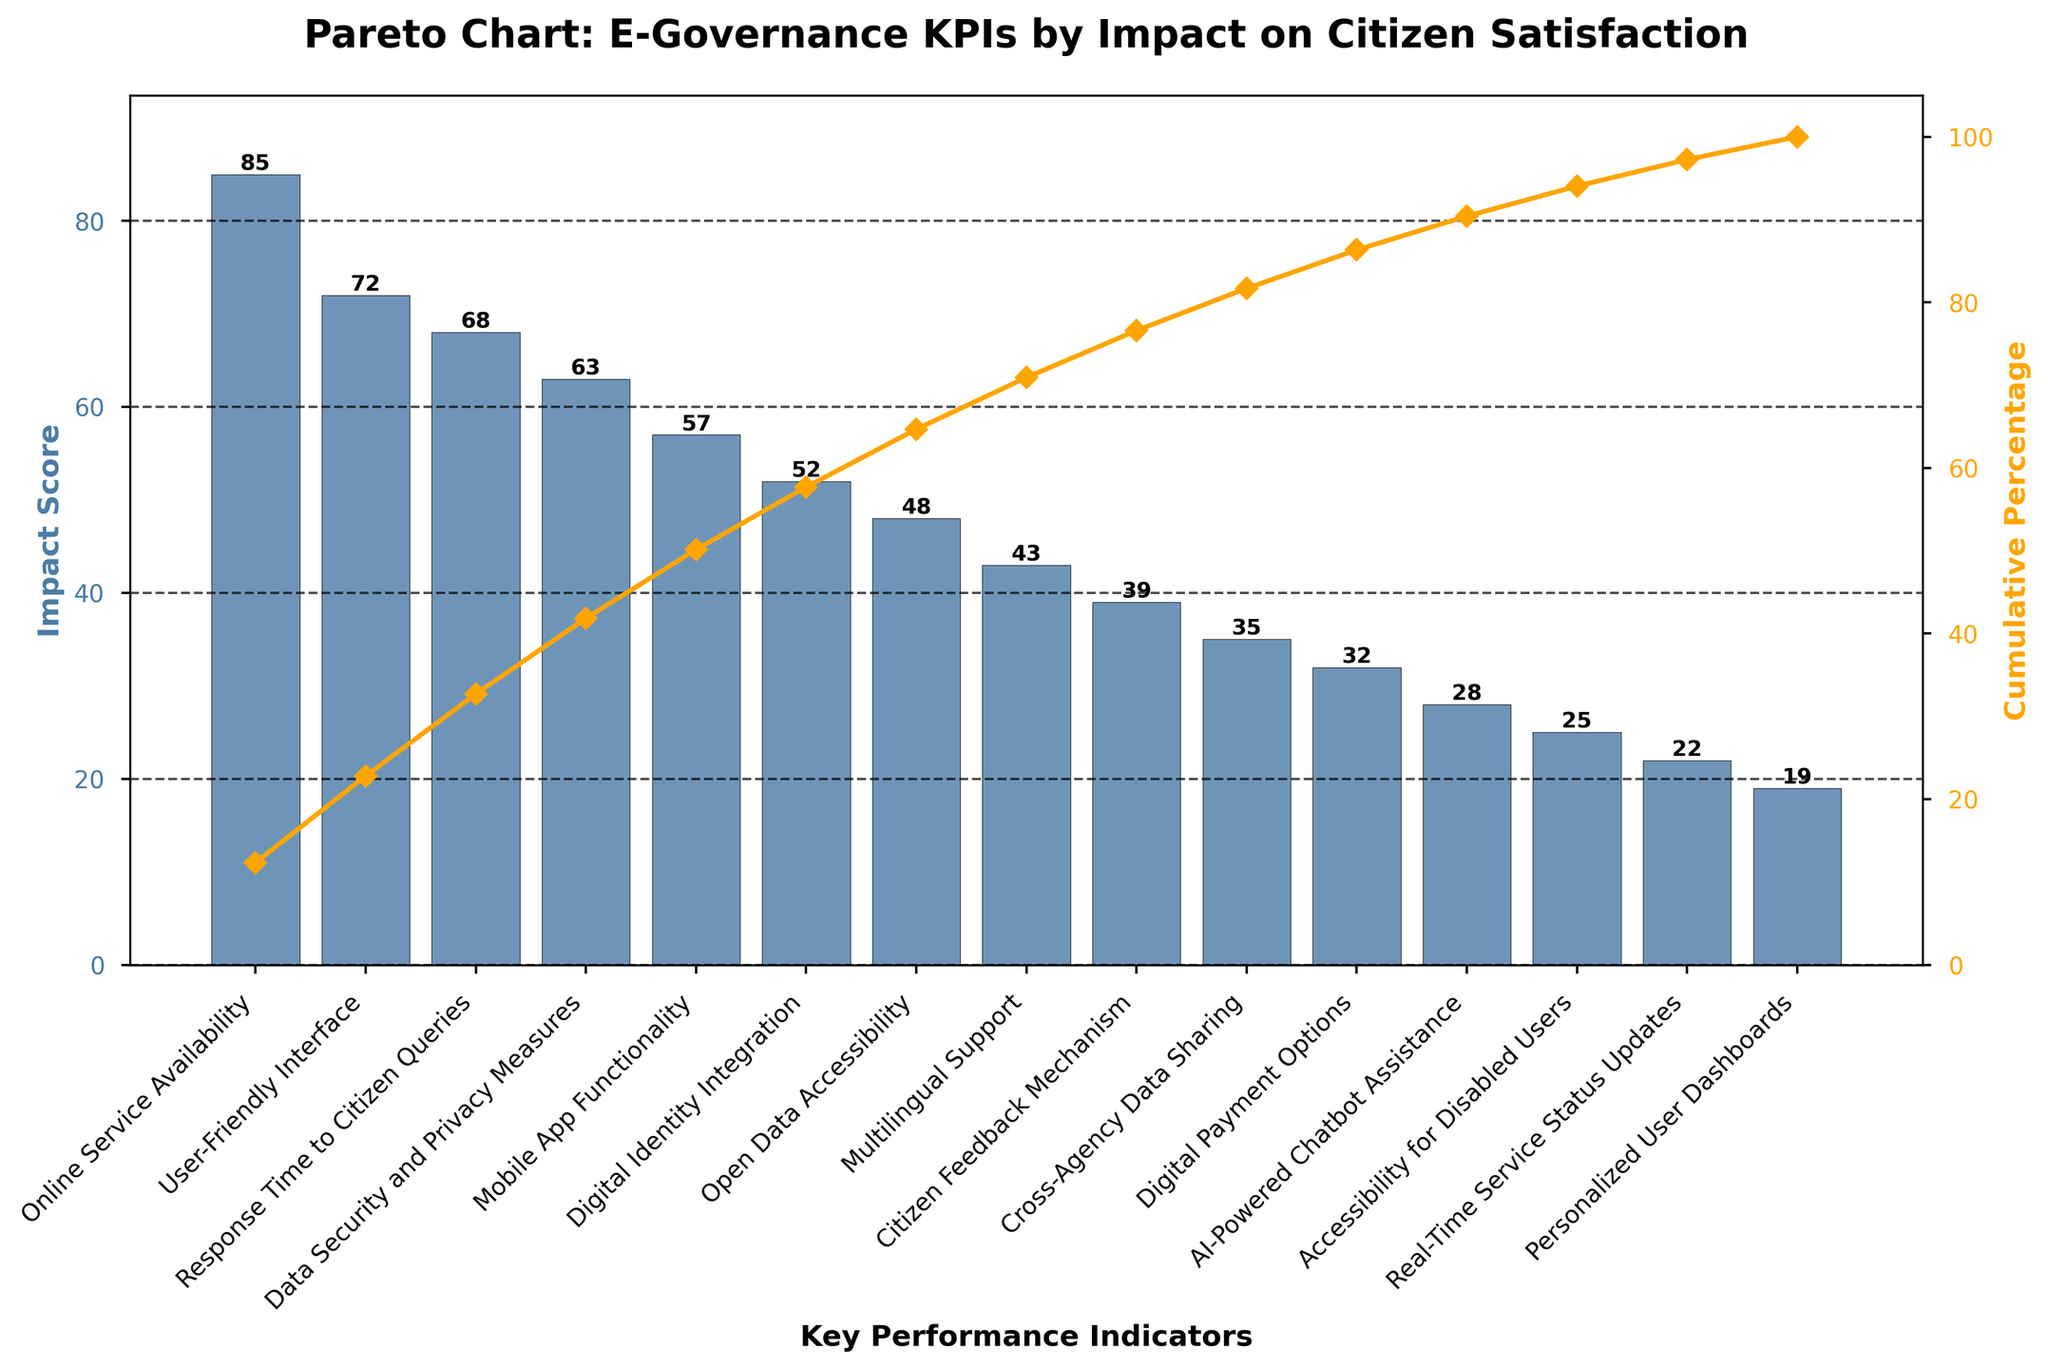What is the title of the chart? The title of the chart is typically placed at the top and is labeled to describe the overall purpose of the chart. In this instance, the title reads "Pareto Chart: E-Governance KPIs by Impact on Citizen Satisfaction".
Answer: Pareto Chart: E-Governance KPIs by Impact on Citizen Satisfaction What is the highest impact score and which KPI does it correspond to? The highest impact score can be identified by looking at the tallest bar in the chart. The tallest bar corresponds to the "Online Service Availability" with an impact score of 85.
Answer: 85, Online Service Availability How many KPIs have an impact score greater than 50? To determine how many KPIs have an impact score greater than 50, look at the bars where the impact score on the y-axis exceeds 50. Count the bars from "Online Service Availability" down to "Digital Identity Integration". This gives us six KPIs.
Answer: 6 What is the cumulative percentage after the top three KPIs? The cumulative percentage line helps identify this. Locate the cumulative percentage where the first three bars end: "Online Service Availability", "User-Friendly Interface", and "Response Time to Citizen Queries". The cumulative percentage at this point is approximately 65%.
Answer: Approximately 65% Which KPI has the lowest impact score, and what is it? The lowest impact score corresponds to the shortest bar in the chart. This bar represents "Personalized User Dashboards" with an impact score of 19.
Answer: Personalized User Dashboards, 19 What is the combined impact score of "Data Security and Privacy Measures" and "Open Data Accessibility"? Look at the height of the bars corresponding to "Data Security and Privacy Measures" (63) and "Open Data Accessibility" (48), and add these values together: 63 + 48 = 111.
Answer: 111 Is the impact of "AI-Powered Chatbot Assistance" greater than "Digital Payment Options"? If so, by how much? Compare the bar heights for "AI-Powered Chatbot Assistance" (28) and "Digital Payment Options" (32). "Digital Payment Options" has a greater impact by 4 points.
Answer: No, 4 points Which KPI marks the 80% cumulative percentage threshold? Follow the cumulative percentage line until it approximately reaches 80%. The corresponding KPI at this threshold is "Digital Identity Integration".
Answer: Digital Identity Integration What is the impact score range of the middle third of KPIs? Divide the total number of KPIs (15) by 3 to get 5 KPIs for the middle third. Identify the bars ranked 6th to 10th: "Digital Identity Integration" (52), "Open Data Accessibility" (48), "Multilingual Support" (43), "Citizen Feedback Mechanism" (39), and "Cross-Agency Data Sharing" (35). The scores range from 35 to 52.
Answer: 35 to 52 